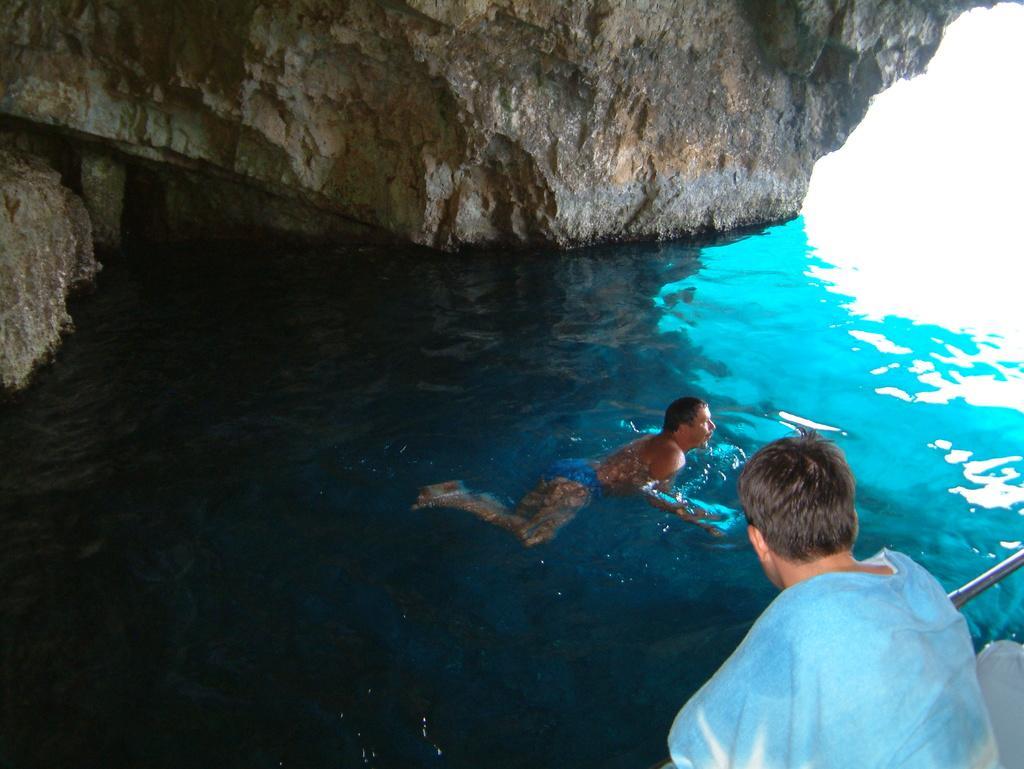Can you describe this image briefly? In this image we see there is a person sitting on the bottom right hand corner and one person swimming on the water. 